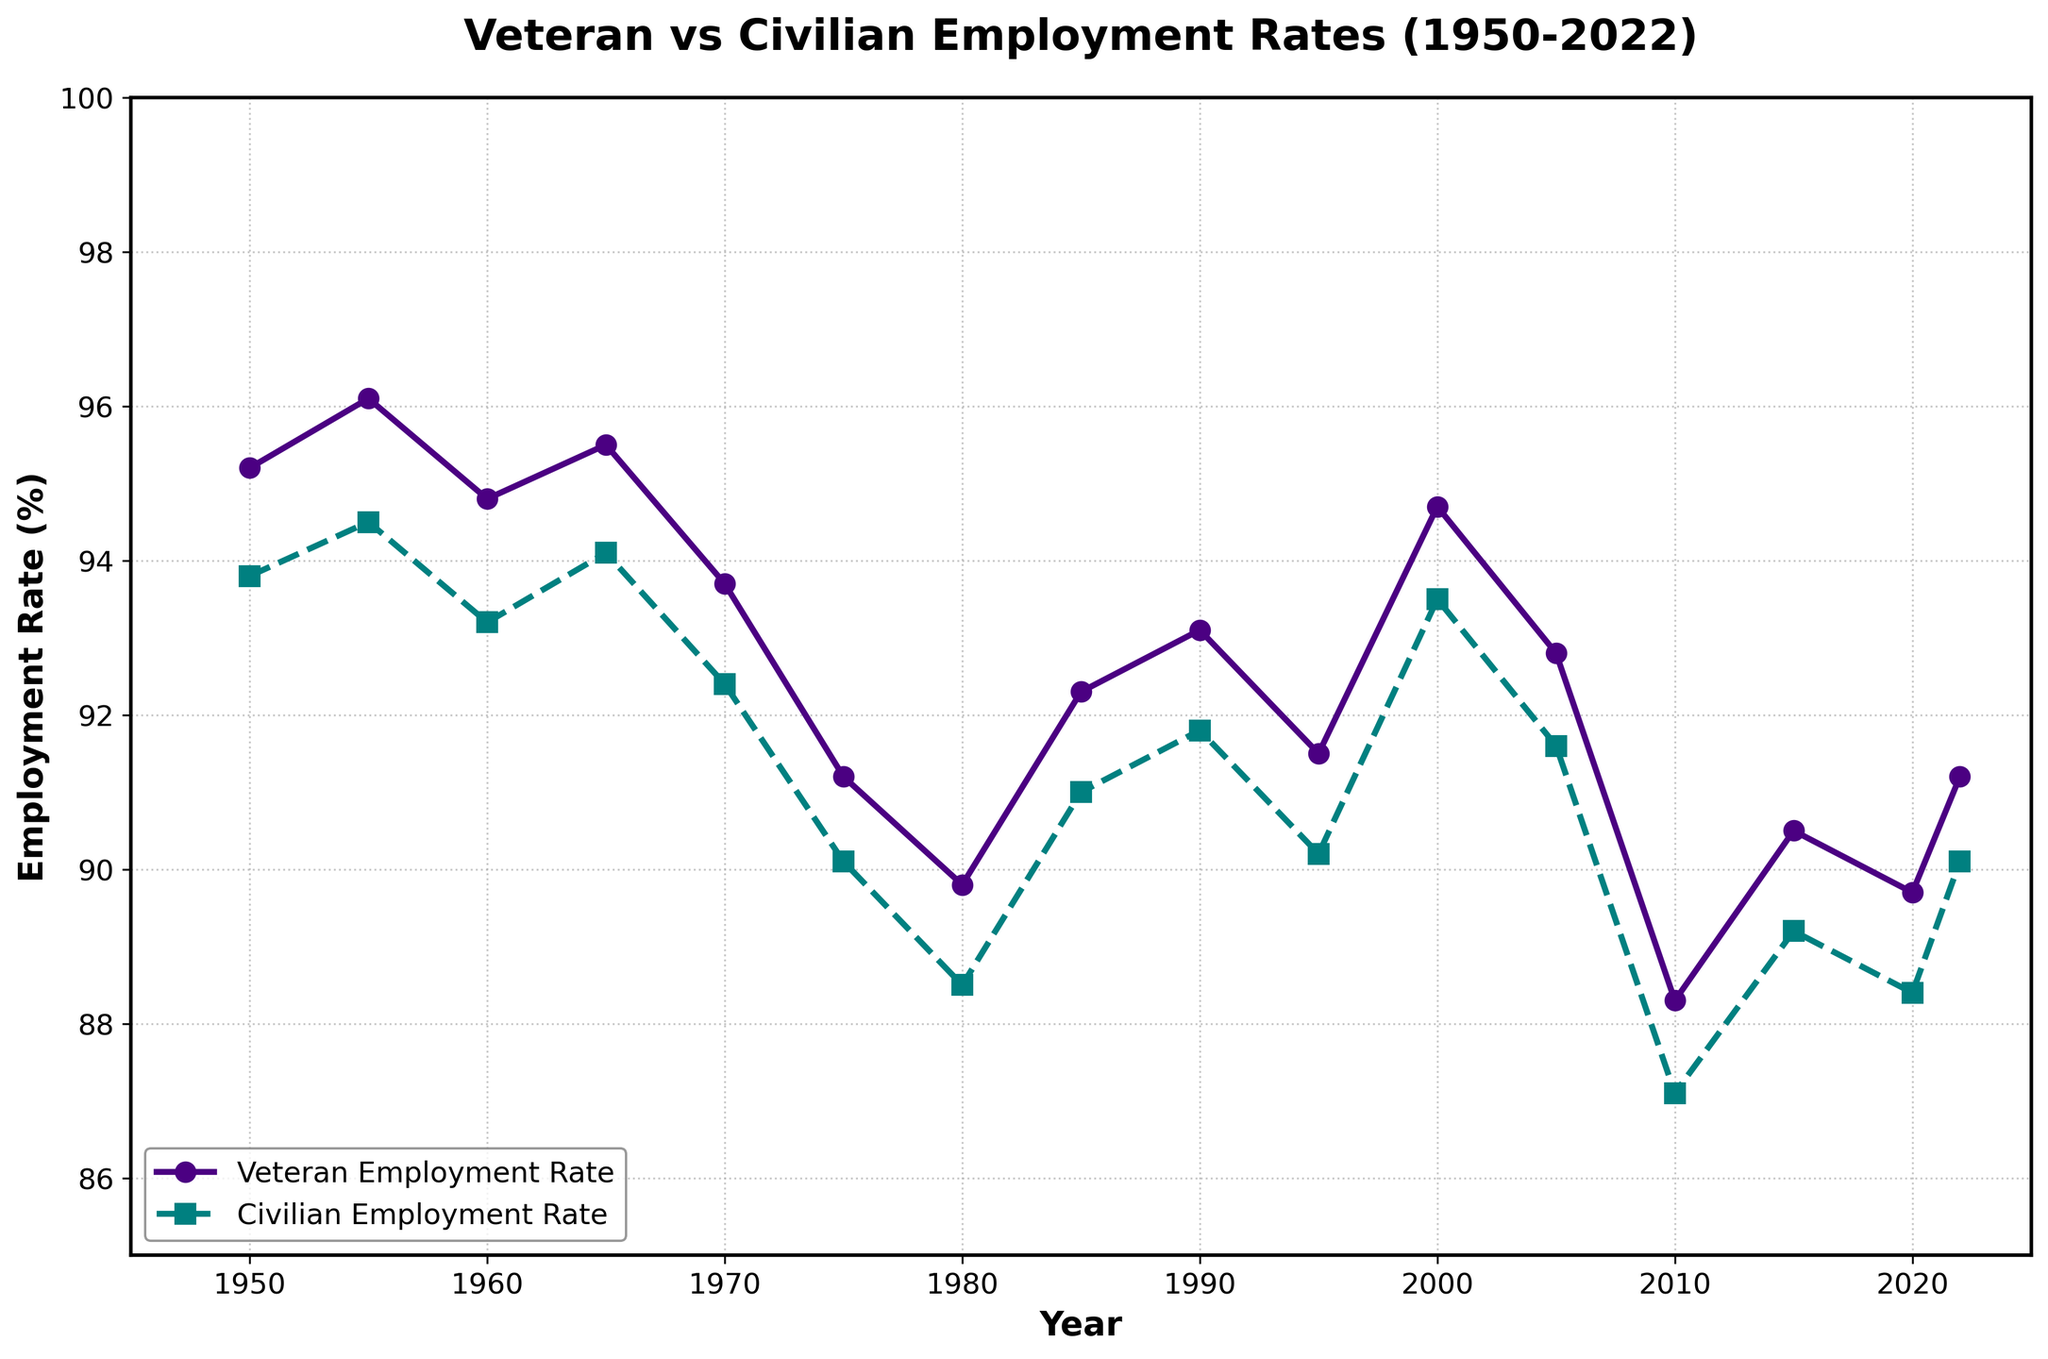Does the veteran employment rate generally trend higher or lower than the civilian employment rate? By visually inspecting the lines, we see that the veteran employment rate (purple line) is often above the civilian employment rate (green line) for most years.
Answer: Higher Which year shows the largest difference between veteran and civilian employment rates? To find the largest difference, we visually check the gaps between the two lines and see that in 1955, the gap is the most noticeable with the veteran rate at 96.1% and the civilian rate at 94.5%, resulting in a difference of 1.6%.
Answer: 1955 Between which years did the veteran employment rate show a noticeable decline, reaching its lowest point? By examining the trend of the veteran employment rate, we observe a discernible decline from 2005 to 2010, where it reached its lowest point at 88.3%.
Answer: 2005 to 2010 How does the veteran employment rate in 2022 compare to that in 1985? We look at the veteran employment rates for both years on the plot, seeing that the rate in 2022 is 91.2%, which is slightly lower than the 92.3% in 1985.
Answer: Lower What is the average employment rate for veterans from 2000 onwards? To find the average, we sum the veteran employment rates from 2000, 2005, 2010, 2015, 2020, and 2022, which are 94.7, 92.8, 88.3, 90.5, 89.7, and 91.2 respectively. Then, we divide the sum by the number of years: (94.7 + 92.8 + 88.3 + 90.5 + 89.7 + 91.2) / 6 = 91.2%.
Answer: 91.2% Between which years did the civilian employment rate remain relatively stable without significant fluctuations? By visually inspecting the line representing the civilian employment rate, we see that from around 1990 to 2005, the rate remains fairly stable, hovering close to 91.8% and 91.6%.
Answer: 1990 to 2005 In which year did the veteran employment rate first drop below 90%? By tracing the veteran employment rate line, we notice that it first drops below 90% in the year 1980, where it stands at 89.8%.
Answer: 1980 Compare the trends in employment rates from 1970 to 1980 for both veterans and civilians. Observing the plots, both rates show a decline. The veteran employment rate decreases from 93.7% to 89.8%, and the civilian rate drops from 92.4% to 88.5%. Both rates show a similar downward trend.
Answer: Both declined What is the cumulative difference in employment rates between veterans and civilians from 1960 to 1965? We find the differences for each year: 1960 - 1.6%, 1965 - 1.4%. The cumulative difference is 1.6 + 1.4 = 3%.
Answer: 3% In what decade did the veteran employment rate see the greatest improvement? By examining the plot, it is clear that the veteran employment rate saw the greatest improvement from 1980 to 1990, rising from 89.8% to 93.1%.
Answer: 1980 to 1990 